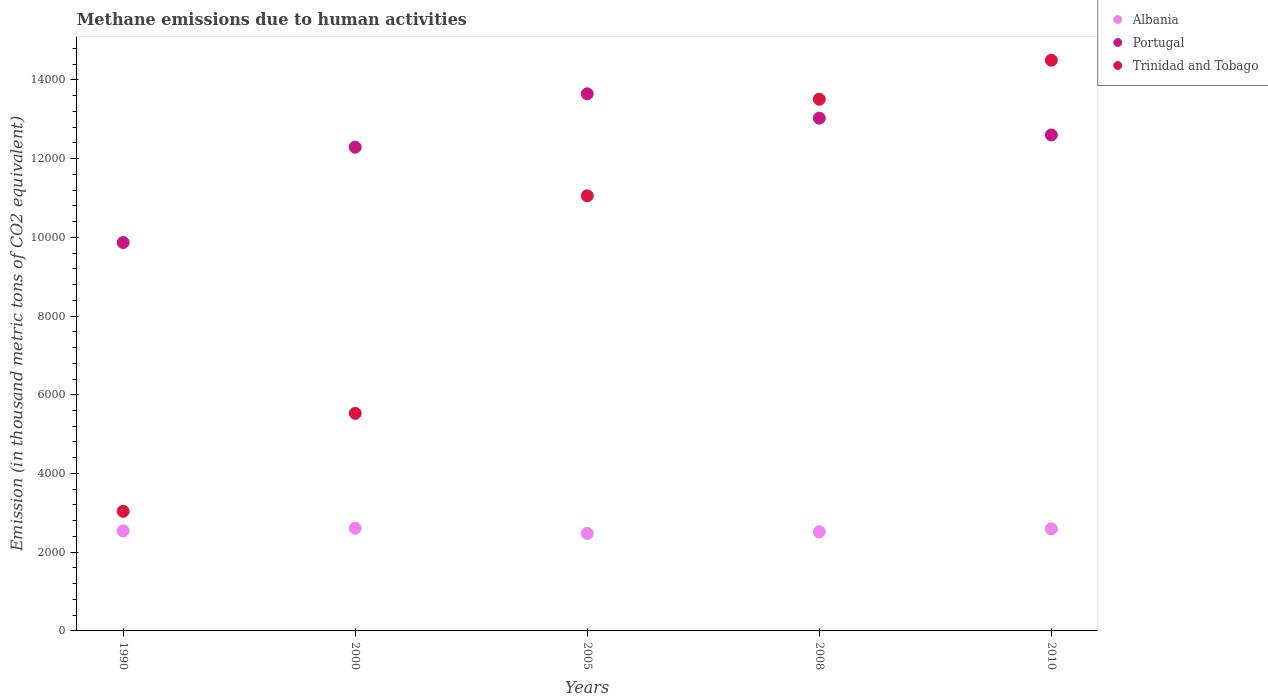What is the amount of methane emitted in Trinidad and Tobago in 2000?
Provide a short and direct response. 5527.5. Across all years, what is the maximum amount of methane emitted in Albania?
Give a very brief answer. 2608.4. Across all years, what is the minimum amount of methane emitted in Portugal?
Provide a short and direct response. 9868.6. In which year was the amount of methane emitted in Trinidad and Tobago minimum?
Ensure brevity in your answer.  1990. What is the total amount of methane emitted in Trinidad and Tobago in the graph?
Provide a short and direct response. 4.76e+04. What is the difference between the amount of methane emitted in Portugal in 2000 and that in 2008?
Your response must be concise. -737.8. What is the difference between the amount of methane emitted in Trinidad and Tobago in 2005 and the amount of methane emitted in Albania in 2008?
Provide a succinct answer. 8538. What is the average amount of methane emitted in Albania per year?
Make the answer very short. 2547.54. In the year 2005, what is the difference between the amount of methane emitted in Trinidad and Tobago and amount of methane emitted in Albania?
Make the answer very short. 8577.6. What is the ratio of the amount of methane emitted in Albania in 2005 to that in 2008?
Offer a very short reply. 0.98. What is the difference between the highest and the second highest amount of methane emitted in Albania?
Ensure brevity in your answer.  15.7. What is the difference between the highest and the lowest amount of methane emitted in Albania?
Your response must be concise. 131.3. Is the sum of the amount of methane emitted in Albania in 2005 and 2010 greater than the maximum amount of methane emitted in Trinidad and Tobago across all years?
Ensure brevity in your answer.  No. Is it the case that in every year, the sum of the amount of methane emitted in Portugal and amount of methane emitted in Albania  is greater than the amount of methane emitted in Trinidad and Tobago?
Your answer should be very brief. Yes. Does the amount of methane emitted in Albania monotonically increase over the years?
Provide a short and direct response. No. Is the amount of methane emitted in Albania strictly less than the amount of methane emitted in Portugal over the years?
Ensure brevity in your answer.  Yes. How many years are there in the graph?
Make the answer very short. 5. Does the graph contain any zero values?
Provide a succinct answer. No. What is the title of the graph?
Your answer should be very brief. Methane emissions due to human activities. What is the label or title of the X-axis?
Ensure brevity in your answer.  Years. What is the label or title of the Y-axis?
Offer a very short reply. Emission (in thousand metric tons of CO2 equivalent). What is the Emission (in thousand metric tons of CO2 equivalent) in Albania in 1990?
Offer a very short reply. 2542.8. What is the Emission (in thousand metric tons of CO2 equivalent) in Portugal in 1990?
Ensure brevity in your answer.  9868.6. What is the Emission (in thousand metric tons of CO2 equivalent) in Trinidad and Tobago in 1990?
Offer a very short reply. 3037.6. What is the Emission (in thousand metric tons of CO2 equivalent) in Albania in 2000?
Offer a very short reply. 2608.4. What is the Emission (in thousand metric tons of CO2 equivalent) of Portugal in 2000?
Offer a very short reply. 1.23e+04. What is the Emission (in thousand metric tons of CO2 equivalent) of Trinidad and Tobago in 2000?
Ensure brevity in your answer.  5527.5. What is the Emission (in thousand metric tons of CO2 equivalent) in Albania in 2005?
Provide a succinct answer. 2477.1. What is the Emission (in thousand metric tons of CO2 equivalent) in Portugal in 2005?
Give a very brief answer. 1.36e+04. What is the Emission (in thousand metric tons of CO2 equivalent) of Trinidad and Tobago in 2005?
Offer a terse response. 1.11e+04. What is the Emission (in thousand metric tons of CO2 equivalent) in Albania in 2008?
Your answer should be compact. 2516.7. What is the Emission (in thousand metric tons of CO2 equivalent) in Portugal in 2008?
Your answer should be very brief. 1.30e+04. What is the Emission (in thousand metric tons of CO2 equivalent) in Trinidad and Tobago in 2008?
Keep it short and to the point. 1.35e+04. What is the Emission (in thousand metric tons of CO2 equivalent) in Albania in 2010?
Offer a terse response. 2592.7. What is the Emission (in thousand metric tons of CO2 equivalent) of Portugal in 2010?
Your answer should be compact. 1.26e+04. What is the Emission (in thousand metric tons of CO2 equivalent) of Trinidad and Tobago in 2010?
Keep it short and to the point. 1.45e+04. Across all years, what is the maximum Emission (in thousand metric tons of CO2 equivalent) of Albania?
Offer a very short reply. 2608.4. Across all years, what is the maximum Emission (in thousand metric tons of CO2 equivalent) of Portugal?
Your answer should be compact. 1.36e+04. Across all years, what is the maximum Emission (in thousand metric tons of CO2 equivalent) of Trinidad and Tobago?
Ensure brevity in your answer.  1.45e+04. Across all years, what is the minimum Emission (in thousand metric tons of CO2 equivalent) in Albania?
Give a very brief answer. 2477.1. Across all years, what is the minimum Emission (in thousand metric tons of CO2 equivalent) in Portugal?
Keep it short and to the point. 9868.6. Across all years, what is the minimum Emission (in thousand metric tons of CO2 equivalent) in Trinidad and Tobago?
Provide a succinct answer. 3037.6. What is the total Emission (in thousand metric tons of CO2 equivalent) of Albania in the graph?
Provide a succinct answer. 1.27e+04. What is the total Emission (in thousand metric tons of CO2 equivalent) of Portugal in the graph?
Your response must be concise. 6.14e+04. What is the total Emission (in thousand metric tons of CO2 equivalent) in Trinidad and Tobago in the graph?
Give a very brief answer. 4.76e+04. What is the difference between the Emission (in thousand metric tons of CO2 equivalent) in Albania in 1990 and that in 2000?
Your answer should be very brief. -65.6. What is the difference between the Emission (in thousand metric tons of CO2 equivalent) in Portugal in 1990 and that in 2000?
Provide a succinct answer. -2420.5. What is the difference between the Emission (in thousand metric tons of CO2 equivalent) in Trinidad and Tobago in 1990 and that in 2000?
Offer a very short reply. -2489.9. What is the difference between the Emission (in thousand metric tons of CO2 equivalent) in Albania in 1990 and that in 2005?
Provide a short and direct response. 65.7. What is the difference between the Emission (in thousand metric tons of CO2 equivalent) in Portugal in 1990 and that in 2005?
Provide a short and direct response. -3778.3. What is the difference between the Emission (in thousand metric tons of CO2 equivalent) of Trinidad and Tobago in 1990 and that in 2005?
Offer a very short reply. -8017.1. What is the difference between the Emission (in thousand metric tons of CO2 equivalent) in Albania in 1990 and that in 2008?
Ensure brevity in your answer.  26.1. What is the difference between the Emission (in thousand metric tons of CO2 equivalent) in Portugal in 1990 and that in 2008?
Give a very brief answer. -3158.3. What is the difference between the Emission (in thousand metric tons of CO2 equivalent) of Trinidad and Tobago in 1990 and that in 2008?
Your response must be concise. -1.05e+04. What is the difference between the Emission (in thousand metric tons of CO2 equivalent) in Albania in 1990 and that in 2010?
Give a very brief answer. -49.9. What is the difference between the Emission (in thousand metric tons of CO2 equivalent) in Portugal in 1990 and that in 2010?
Provide a short and direct response. -2731.9. What is the difference between the Emission (in thousand metric tons of CO2 equivalent) of Trinidad and Tobago in 1990 and that in 2010?
Provide a short and direct response. -1.15e+04. What is the difference between the Emission (in thousand metric tons of CO2 equivalent) in Albania in 2000 and that in 2005?
Provide a succinct answer. 131.3. What is the difference between the Emission (in thousand metric tons of CO2 equivalent) in Portugal in 2000 and that in 2005?
Keep it short and to the point. -1357.8. What is the difference between the Emission (in thousand metric tons of CO2 equivalent) of Trinidad and Tobago in 2000 and that in 2005?
Your answer should be compact. -5527.2. What is the difference between the Emission (in thousand metric tons of CO2 equivalent) of Albania in 2000 and that in 2008?
Ensure brevity in your answer.  91.7. What is the difference between the Emission (in thousand metric tons of CO2 equivalent) in Portugal in 2000 and that in 2008?
Keep it short and to the point. -737.8. What is the difference between the Emission (in thousand metric tons of CO2 equivalent) of Trinidad and Tobago in 2000 and that in 2008?
Give a very brief answer. -7981.1. What is the difference between the Emission (in thousand metric tons of CO2 equivalent) of Albania in 2000 and that in 2010?
Provide a succinct answer. 15.7. What is the difference between the Emission (in thousand metric tons of CO2 equivalent) of Portugal in 2000 and that in 2010?
Offer a very short reply. -311.4. What is the difference between the Emission (in thousand metric tons of CO2 equivalent) in Trinidad and Tobago in 2000 and that in 2010?
Ensure brevity in your answer.  -8971.6. What is the difference between the Emission (in thousand metric tons of CO2 equivalent) of Albania in 2005 and that in 2008?
Offer a very short reply. -39.6. What is the difference between the Emission (in thousand metric tons of CO2 equivalent) of Portugal in 2005 and that in 2008?
Provide a short and direct response. 620. What is the difference between the Emission (in thousand metric tons of CO2 equivalent) of Trinidad and Tobago in 2005 and that in 2008?
Provide a short and direct response. -2453.9. What is the difference between the Emission (in thousand metric tons of CO2 equivalent) in Albania in 2005 and that in 2010?
Your answer should be compact. -115.6. What is the difference between the Emission (in thousand metric tons of CO2 equivalent) of Portugal in 2005 and that in 2010?
Provide a short and direct response. 1046.4. What is the difference between the Emission (in thousand metric tons of CO2 equivalent) in Trinidad and Tobago in 2005 and that in 2010?
Offer a terse response. -3444.4. What is the difference between the Emission (in thousand metric tons of CO2 equivalent) of Albania in 2008 and that in 2010?
Make the answer very short. -76. What is the difference between the Emission (in thousand metric tons of CO2 equivalent) of Portugal in 2008 and that in 2010?
Offer a very short reply. 426.4. What is the difference between the Emission (in thousand metric tons of CO2 equivalent) in Trinidad and Tobago in 2008 and that in 2010?
Your response must be concise. -990.5. What is the difference between the Emission (in thousand metric tons of CO2 equivalent) in Albania in 1990 and the Emission (in thousand metric tons of CO2 equivalent) in Portugal in 2000?
Provide a succinct answer. -9746.3. What is the difference between the Emission (in thousand metric tons of CO2 equivalent) of Albania in 1990 and the Emission (in thousand metric tons of CO2 equivalent) of Trinidad and Tobago in 2000?
Your response must be concise. -2984.7. What is the difference between the Emission (in thousand metric tons of CO2 equivalent) in Portugal in 1990 and the Emission (in thousand metric tons of CO2 equivalent) in Trinidad and Tobago in 2000?
Offer a very short reply. 4341.1. What is the difference between the Emission (in thousand metric tons of CO2 equivalent) of Albania in 1990 and the Emission (in thousand metric tons of CO2 equivalent) of Portugal in 2005?
Your answer should be compact. -1.11e+04. What is the difference between the Emission (in thousand metric tons of CO2 equivalent) of Albania in 1990 and the Emission (in thousand metric tons of CO2 equivalent) of Trinidad and Tobago in 2005?
Keep it short and to the point. -8511.9. What is the difference between the Emission (in thousand metric tons of CO2 equivalent) of Portugal in 1990 and the Emission (in thousand metric tons of CO2 equivalent) of Trinidad and Tobago in 2005?
Offer a very short reply. -1186.1. What is the difference between the Emission (in thousand metric tons of CO2 equivalent) of Albania in 1990 and the Emission (in thousand metric tons of CO2 equivalent) of Portugal in 2008?
Keep it short and to the point. -1.05e+04. What is the difference between the Emission (in thousand metric tons of CO2 equivalent) of Albania in 1990 and the Emission (in thousand metric tons of CO2 equivalent) of Trinidad and Tobago in 2008?
Provide a short and direct response. -1.10e+04. What is the difference between the Emission (in thousand metric tons of CO2 equivalent) of Portugal in 1990 and the Emission (in thousand metric tons of CO2 equivalent) of Trinidad and Tobago in 2008?
Your answer should be compact. -3640. What is the difference between the Emission (in thousand metric tons of CO2 equivalent) in Albania in 1990 and the Emission (in thousand metric tons of CO2 equivalent) in Portugal in 2010?
Give a very brief answer. -1.01e+04. What is the difference between the Emission (in thousand metric tons of CO2 equivalent) of Albania in 1990 and the Emission (in thousand metric tons of CO2 equivalent) of Trinidad and Tobago in 2010?
Offer a very short reply. -1.20e+04. What is the difference between the Emission (in thousand metric tons of CO2 equivalent) in Portugal in 1990 and the Emission (in thousand metric tons of CO2 equivalent) in Trinidad and Tobago in 2010?
Keep it short and to the point. -4630.5. What is the difference between the Emission (in thousand metric tons of CO2 equivalent) of Albania in 2000 and the Emission (in thousand metric tons of CO2 equivalent) of Portugal in 2005?
Your answer should be compact. -1.10e+04. What is the difference between the Emission (in thousand metric tons of CO2 equivalent) in Albania in 2000 and the Emission (in thousand metric tons of CO2 equivalent) in Trinidad and Tobago in 2005?
Your response must be concise. -8446.3. What is the difference between the Emission (in thousand metric tons of CO2 equivalent) in Portugal in 2000 and the Emission (in thousand metric tons of CO2 equivalent) in Trinidad and Tobago in 2005?
Offer a terse response. 1234.4. What is the difference between the Emission (in thousand metric tons of CO2 equivalent) in Albania in 2000 and the Emission (in thousand metric tons of CO2 equivalent) in Portugal in 2008?
Make the answer very short. -1.04e+04. What is the difference between the Emission (in thousand metric tons of CO2 equivalent) of Albania in 2000 and the Emission (in thousand metric tons of CO2 equivalent) of Trinidad and Tobago in 2008?
Offer a terse response. -1.09e+04. What is the difference between the Emission (in thousand metric tons of CO2 equivalent) of Portugal in 2000 and the Emission (in thousand metric tons of CO2 equivalent) of Trinidad and Tobago in 2008?
Offer a very short reply. -1219.5. What is the difference between the Emission (in thousand metric tons of CO2 equivalent) in Albania in 2000 and the Emission (in thousand metric tons of CO2 equivalent) in Portugal in 2010?
Your answer should be very brief. -9992.1. What is the difference between the Emission (in thousand metric tons of CO2 equivalent) in Albania in 2000 and the Emission (in thousand metric tons of CO2 equivalent) in Trinidad and Tobago in 2010?
Your answer should be compact. -1.19e+04. What is the difference between the Emission (in thousand metric tons of CO2 equivalent) in Portugal in 2000 and the Emission (in thousand metric tons of CO2 equivalent) in Trinidad and Tobago in 2010?
Your response must be concise. -2210. What is the difference between the Emission (in thousand metric tons of CO2 equivalent) of Albania in 2005 and the Emission (in thousand metric tons of CO2 equivalent) of Portugal in 2008?
Make the answer very short. -1.05e+04. What is the difference between the Emission (in thousand metric tons of CO2 equivalent) of Albania in 2005 and the Emission (in thousand metric tons of CO2 equivalent) of Trinidad and Tobago in 2008?
Your response must be concise. -1.10e+04. What is the difference between the Emission (in thousand metric tons of CO2 equivalent) in Portugal in 2005 and the Emission (in thousand metric tons of CO2 equivalent) in Trinidad and Tobago in 2008?
Your answer should be very brief. 138.3. What is the difference between the Emission (in thousand metric tons of CO2 equivalent) of Albania in 2005 and the Emission (in thousand metric tons of CO2 equivalent) of Portugal in 2010?
Make the answer very short. -1.01e+04. What is the difference between the Emission (in thousand metric tons of CO2 equivalent) in Albania in 2005 and the Emission (in thousand metric tons of CO2 equivalent) in Trinidad and Tobago in 2010?
Provide a succinct answer. -1.20e+04. What is the difference between the Emission (in thousand metric tons of CO2 equivalent) in Portugal in 2005 and the Emission (in thousand metric tons of CO2 equivalent) in Trinidad and Tobago in 2010?
Provide a succinct answer. -852.2. What is the difference between the Emission (in thousand metric tons of CO2 equivalent) in Albania in 2008 and the Emission (in thousand metric tons of CO2 equivalent) in Portugal in 2010?
Your answer should be compact. -1.01e+04. What is the difference between the Emission (in thousand metric tons of CO2 equivalent) in Albania in 2008 and the Emission (in thousand metric tons of CO2 equivalent) in Trinidad and Tobago in 2010?
Your response must be concise. -1.20e+04. What is the difference between the Emission (in thousand metric tons of CO2 equivalent) in Portugal in 2008 and the Emission (in thousand metric tons of CO2 equivalent) in Trinidad and Tobago in 2010?
Offer a very short reply. -1472.2. What is the average Emission (in thousand metric tons of CO2 equivalent) in Albania per year?
Ensure brevity in your answer.  2547.54. What is the average Emission (in thousand metric tons of CO2 equivalent) in Portugal per year?
Ensure brevity in your answer.  1.23e+04. What is the average Emission (in thousand metric tons of CO2 equivalent) in Trinidad and Tobago per year?
Ensure brevity in your answer.  9525.5. In the year 1990, what is the difference between the Emission (in thousand metric tons of CO2 equivalent) of Albania and Emission (in thousand metric tons of CO2 equivalent) of Portugal?
Your answer should be compact. -7325.8. In the year 1990, what is the difference between the Emission (in thousand metric tons of CO2 equivalent) in Albania and Emission (in thousand metric tons of CO2 equivalent) in Trinidad and Tobago?
Make the answer very short. -494.8. In the year 1990, what is the difference between the Emission (in thousand metric tons of CO2 equivalent) of Portugal and Emission (in thousand metric tons of CO2 equivalent) of Trinidad and Tobago?
Ensure brevity in your answer.  6831. In the year 2000, what is the difference between the Emission (in thousand metric tons of CO2 equivalent) in Albania and Emission (in thousand metric tons of CO2 equivalent) in Portugal?
Ensure brevity in your answer.  -9680.7. In the year 2000, what is the difference between the Emission (in thousand metric tons of CO2 equivalent) of Albania and Emission (in thousand metric tons of CO2 equivalent) of Trinidad and Tobago?
Your answer should be very brief. -2919.1. In the year 2000, what is the difference between the Emission (in thousand metric tons of CO2 equivalent) in Portugal and Emission (in thousand metric tons of CO2 equivalent) in Trinidad and Tobago?
Keep it short and to the point. 6761.6. In the year 2005, what is the difference between the Emission (in thousand metric tons of CO2 equivalent) of Albania and Emission (in thousand metric tons of CO2 equivalent) of Portugal?
Offer a terse response. -1.12e+04. In the year 2005, what is the difference between the Emission (in thousand metric tons of CO2 equivalent) in Albania and Emission (in thousand metric tons of CO2 equivalent) in Trinidad and Tobago?
Keep it short and to the point. -8577.6. In the year 2005, what is the difference between the Emission (in thousand metric tons of CO2 equivalent) in Portugal and Emission (in thousand metric tons of CO2 equivalent) in Trinidad and Tobago?
Give a very brief answer. 2592.2. In the year 2008, what is the difference between the Emission (in thousand metric tons of CO2 equivalent) in Albania and Emission (in thousand metric tons of CO2 equivalent) in Portugal?
Offer a terse response. -1.05e+04. In the year 2008, what is the difference between the Emission (in thousand metric tons of CO2 equivalent) in Albania and Emission (in thousand metric tons of CO2 equivalent) in Trinidad and Tobago?
Your response must be concise. -1.10e+04. In the year 2008, what is the difference between the Emission (in thousand metric tons of CO2 equivalent) of Portugal and Emission (in thousand metric tons of CO2 equivalent) of Trinidad and Tobago?
Provide a short and direct response. -481.7. In the year 2010, what is the difference between the Emission (in thousand metric tons of CO2 equivalent) of Albania and Emission (in thousand metric tons of CO2 equivalent) of Portugal?
Your answer should be compact. -1.00e+04. In the year 2010, what is the difference between the Emission (in thousand metric tons of CO2 equivalent) in Albania and Emission (in thousand metric tons of CO2 equivalent) in Trinidad and Tobago?
Ensure brevity in your answer.  -1.19e+04. In the year 2010, what is the difference between the Emission (in thousand metric tons of CO2 equivalent) of Portugal and Emission (in thousand metric tons of CO2 equivalent) of Trinidad and Tobago?
Provide a succinct answer. -1898.6. What is the ratio of the Emission (in thousand metric tons of CO2 equivalent) in Albania in 1990 to that in 2000?
Ensure brevity in your answer.  0.97. What is the ratio of the Emission (in thousand metric tons of CO2 equivalent) of Portugal in 1990 to that in 2000?
Make the answer very short. 0.8. What is the ratio of the Emission (in thousand metric tons of CO2 equivalent) in Trinidad and Tobago in 1990 to that in 2000?
Keep it short and to the point. 0.55. What is the ratio of the Emission (in thousand metric tons of CO2 equivalent) of Albania in 1990 to that in 2005?
Keep it short and to the point. 1.03. What is the ratio of the Emission (in thousand metric tons of CO2 equivalent) in Portugal in 1990 to that in 2005?
Your answer should be very brief. 0.72. What is the ratio of the Emission (in thousand metric tons of CO2 equivalent) in Trinidad and Tobago in 1990 to that in 2005?
Your answer should be very brief. 0.27. What is the ratio of the Emission (in thousand metric tons of CO2 equivalent) of Albania in 1990 to that in 2008?
Your response must be concise. 1.01. What is the ratio of the Emission (in thousand metric tons of CO2 equivalent) in Portugal in 1990 to that in 2008?
Your answer should be very brief. 0.76. What is the ratio of the Emission (in thousand metric tons of CO2 equivalent) in Trinidad and Tobago in 1990 to that in 2008?
Your answer should be very brief. 0.22. What is the ratio of the Emission (in thousand metric tons of CO2 equivalent) in Albania in 1990 to that in 2010?
Give a very brief answer. 0.98. What is the ratio of the Emission (in thousand metric tons of CO2 equivalent) of Portugal in 1990 to that in 2010?
Ensure brevity in your answer.  0.78. What is the ratio of the Emission (in thousand metric tons of CO2 equivalent) of Trinidad and Tobago in 1990 to that in 2010?
Offer a very short reply. 0.21. What is the ratio of the Emission (in thousand metric tons of CO2 equivalent) in Albania in 2000 to that in 2005?
Your answer should be compact. 1.05. What is the ratio of the Emission (in thousand metric tons of CO2 equivalent) in Portugal in 2000 to that in 2005?
Provide a short and direct response. 0.9. What is the ratio of the Emission (in thousand metric tons of CO2 equivalent) in Trinidad and Tobago in 2000 to that in 2005?
Make the answer very short. 0.5. What is the ratio of the Emission (in thousand metric tons of CO2 equivalent) of Albania in 2000 to that in 2008?
Your answer should be very brief. 1.04. What is the ratio of the Emission (in thousand metric tons of CO2 equivalent) of Portugal in 2000 to that in 2008?
Provide a succinct answer. 0.94. What is the ratio of the Emission (in thousand metric tons of CO2 equivalent) in Trinidad and Tobago in 2000 to that in 2008?
Your answer should be very brief. 0.41. What is the ratio of the Emission (in thousand metric tons of CO2 equivalent) in Portugal in 2000 to that in 2010?
Your response must be concise. 0.98. What is the ratio of the Emission (in thousand metric tons of CO2 equivalent) in Trinidad and Tobago in 2000 to that in 2010?
Make the answer very short. 0.38. What is the ratio of the Emission (in thousand metric tons of CO2 equivalent) in Albania in 2005 to that in 2008?
Your response must be concise. 0.98. What is the ratio of the Emission (in thousand metric tons of CO2 equivalent) in Portugal in 2005 to that in 2008?
Your response must be concise. 1.05. What is the ratio of the Emission (in thousand metric tons of CO2 equivalent) of Trinidad and Tobago in 2005 to that in 2008?
Offer a very short reply. 0.82. What is the ratio of the Emission (in thousand metric tons of CO2 equivalent) in Albania in 2005 to that in 2010?
Give a very brief answer. 0.96. What is the ratio of the Emission (in thousand metric tons of CO2 equivalent) of Portugal in 2005 to that in 2010?
Your answer should be very brief. 1.08. What is the ratio of the Emission (in thousand metric tons of CO2 equivalent) of Trinidad and Tobago in 2005 to that in 2010?
Your response must be concise. 0.76. What is the ratio of the Emission (in thousand metric tons of CO2 equivalent) of Albania in 2008 to that in 2010?
Your answer should be very brief. 0.97. What is the ratio of the Emission (in thousand metric tons of CO2 equivalent) in Portugal in 2008 to that in 2010?
Keep it short and to the point. 1.03. What is the ratio of the Emission (in thousand metric tons of CO2 equivalent) of Trinidad and Tobago in 2008 to that in 2010?
Ensure brevity in your answer.  0.93. What is the difference between the highest and the second highest Emission (in thousand metric tons of CO2 equivalent) in Albania?
Your response must be concise. 15.7. What is the difference between the highest and the second highest Emission (in thousand metric tons of CO2 equivalent) in Portugal?
Ensure brevity in your answer.  620. What is the difference between the highest and the second highest Emission (in thousand metric tons of CO2 equivalent) of Trinidad and Tobago?
Give a very brief answer. 990.5. What is the difference between the highest and the lowest Emission (in thousand metric tons of CO2 equivalent) in Albania?
Give a very brief answer. 131.3. What is the difference between the highest and the lowest Emission (in thousand metric tons of CO2 equivalent) in Portugal?
Your answer should be compact. 3778.3. What is the difference between the highest and the lowest Emission (in thousand metric tons of CO2 equivalent) of Trinidad and Tobago?
Ensure brevity in your answer.  1.15e+04. 